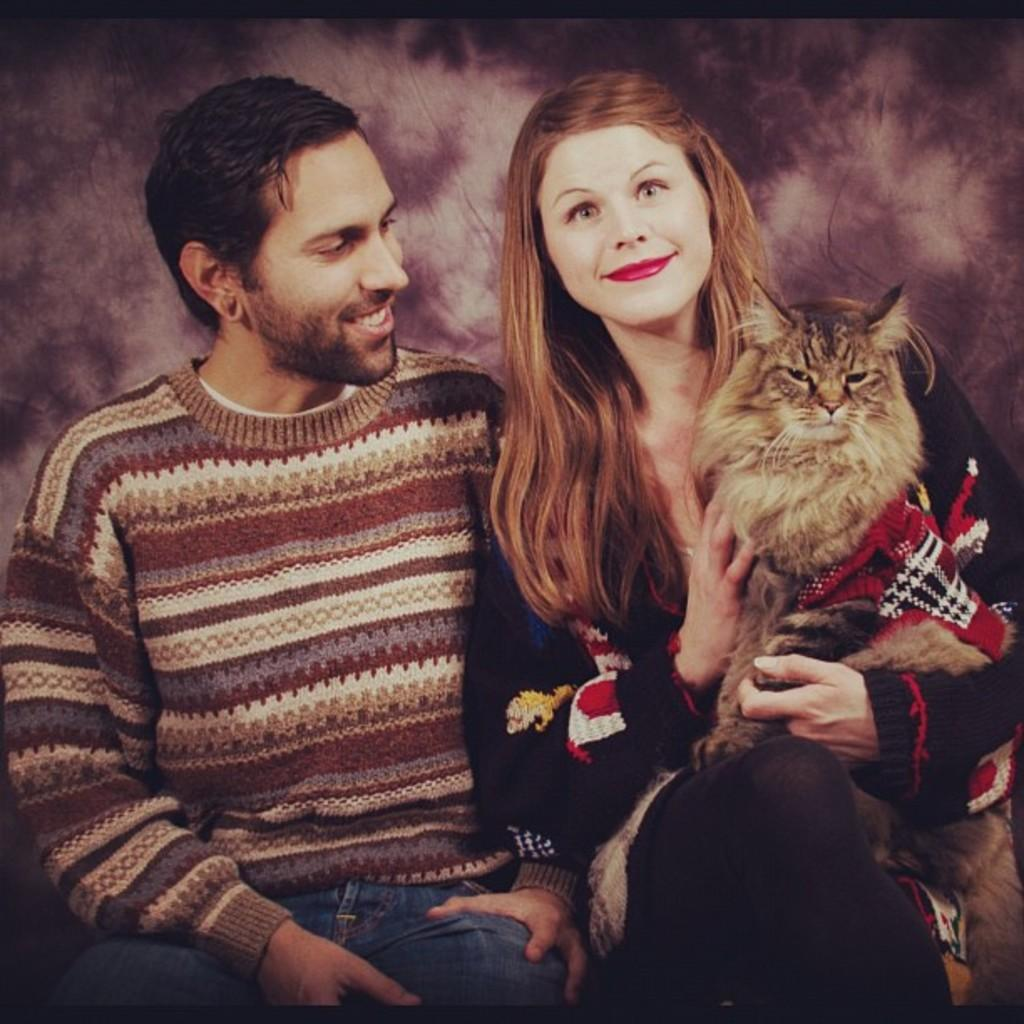What is the man in the image doing? The man is sitting in the image. What is the man wearing? The man is wearing a sweater. Who else is present in the image? There is a woman in the image. What is the woman doing? The woman is sitting in the image. What is the woman holding? The woman is holding a cat. What is the woman wearing? The woman is wearing a black dress. What type of tax is being discussed in the image? There is no mention of tax or any discussion about it in the image. 